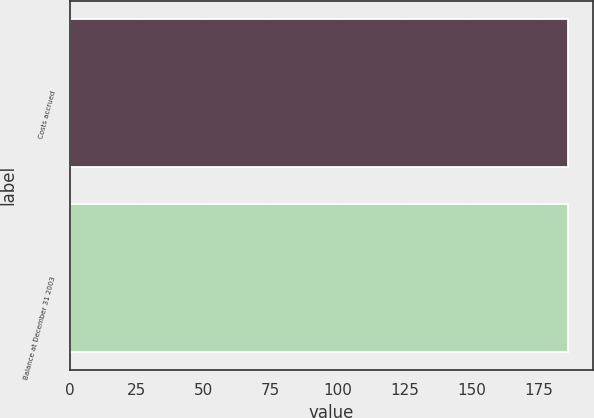<chart> <loc_0><loc_0><loc_500><loc_500><bar_chart><fcel>Costs accrued<fcel>Balance at December 31 2003<nl><fcel>186<fcel>186.1<nl></chart> 